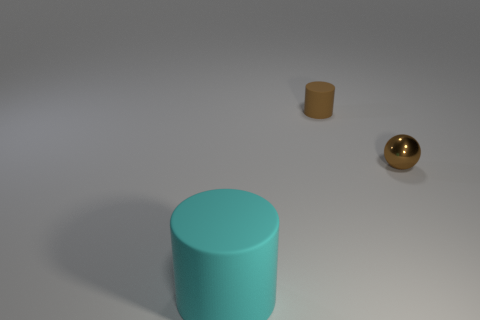There is a cyan object; is its size the same as the rubber thing behind the tiny metal thing?
Ensure brevity in your answer.  No. How many rubber objects are either small brown cylinders or big objects?
Your answer should be compact. 2. How many tiny brown rubber objects are the same shape as the small shiny object?
Your answer should be very brief. 0. There is a small cylinder that is the same color as the small shiny thing; what is it made of?
Your answer should be compact. Rubber. There is a matte cylinder that is in front of the brown sphere; does it have the same size as the cylinder that is behind the cyan matte thing?
Offer a very short reply. No. There is a matte object that is behind the cyan matte object; what is its shape?
Offer a very short reply. Cylinder. Is the number of brown balls the same as the number of tiny objects?
Provide a short and direct response. No. What material is the other thing that is the same shape as the large rubber thing?
Your answer should be very brief. Rubber. Do the brown object to the right of the brown rubber thing and the tiny brown cylinder have the same size?
Your answer should be compact. Yes. There is a brown shiny thing; what number of cylinders are in front of it?
Your answer should be compact. 1. 